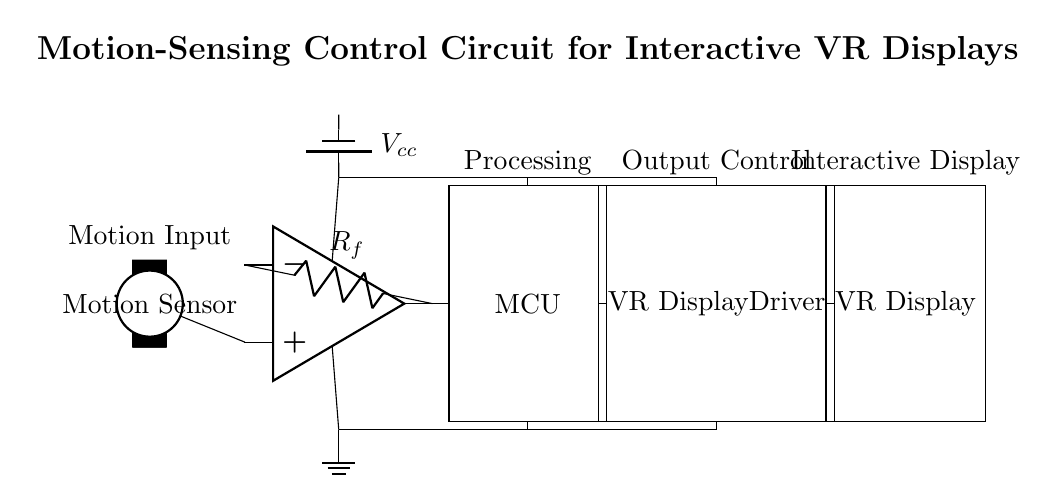What component detects motion in this circuit? The component responsible for detecting motion is labeled as "Motion Sensor" in the diagram. This denotes its primary function in the circuit.
Answer: Motion Sensor What is the role of the op-amp in this circuit? The op-amp, shown as an operational amplifier, serves to amplify the signal received from the motion sensor, ensuring that the signal is strong enough for the microcontroller to process effectively.
Answer: Amplification How many main components are involved in this circuit? The main components are the Motion Sensor, Op-Amp, Microcontroller, VR Display Driver, and VR Display, totaling five distinct components in the circuit.
Answer: Five What is the power supply voltage indicated in the circuit? The power supply voltage is labeled as \( V_{cc} \), which typically represents the voltage supplied to the components. The specific voltage value would need to be referenced from additional documentation, but the label is clear in the circuit.
Answer: \( V_{cc} \) What is the signal flow direction from the motion sensor to the VR display? The signal flow begins at the Motion Sensor, proceeds through the Op-Amp, moves to the Microcontroller, goes through the VR Display Driver, and finally reaches the VR Display, indicating a sequential path for the signal.
Answer: Sequential path What type of circuit is this? This circuit is a motion-sensing control circuit specifically designed for interactive virtual reality displays, indicated by its components and their arrangement in the visual representation.
Answer: Motion-Sensing Control Circuit What is the output device in this control circuit? The output device in this circuit is labeled as "VR Display", which indicates it is the final component receiving processed signals to produce an interactive visual experience.
Answer: VR Display 